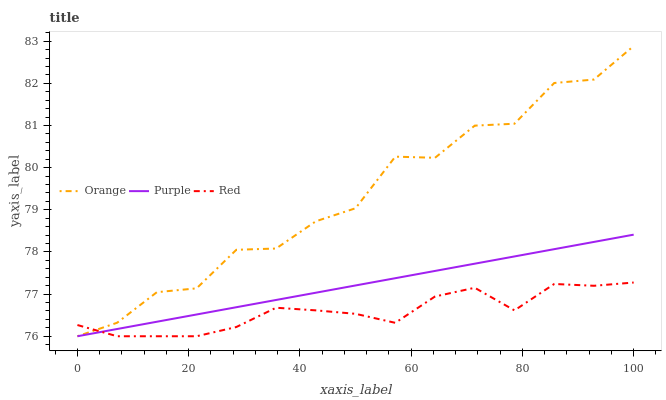Does Red have the minimum area under the curve?
Answer yes or no. Yes. Does Orange have the maximum area under the curve?
Answer yes or no. Yes. Does Purple have the minimum area under the curve?
Answer yes or no. No. Does Purple have the maximum area under the curve?
Answer yes or no. No. Is Purple the smoothest?
Answer yes or no. Yes. Is Orange the roughest?
Answer yes or no. Yes. Is Red the smoothest?
Answer yes or no. No. Is Red the roughest?
Answer yes or no. No. Does Orange have the lowest value?
Answer yes or no. Yes. Does Orange have the highest value?
Answer yes or no. Yes. Does Purple have the highest value?
Answer yes or no. No. Does Purple intersect Orange?
Answer yes or no. Yes. Is Purple less than Orange?
Answer yes or no. No. Is Purple greater than Orange?
Answer yes or no. No. 